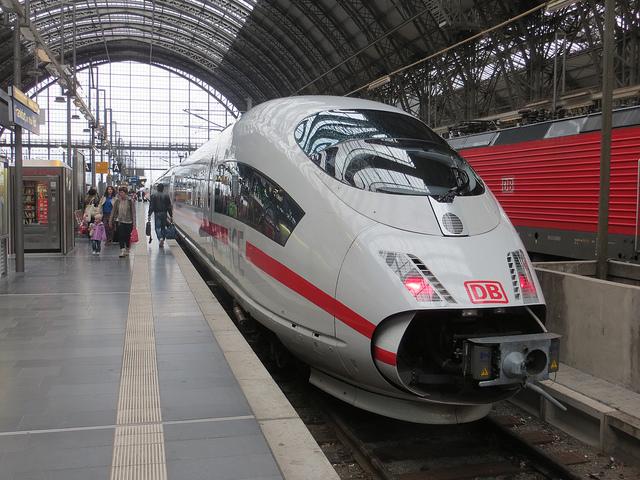Is she taking a picture?
Keep it brief. No. Is this a modern train?
Short answer required. Yes. Are there people in the picture?
Short answer required. Yes. Is the train old?
Write a very short answer. No. What is the red thing on the right?
Short answer required. Train. What color is that train?
Be succinct. White. 